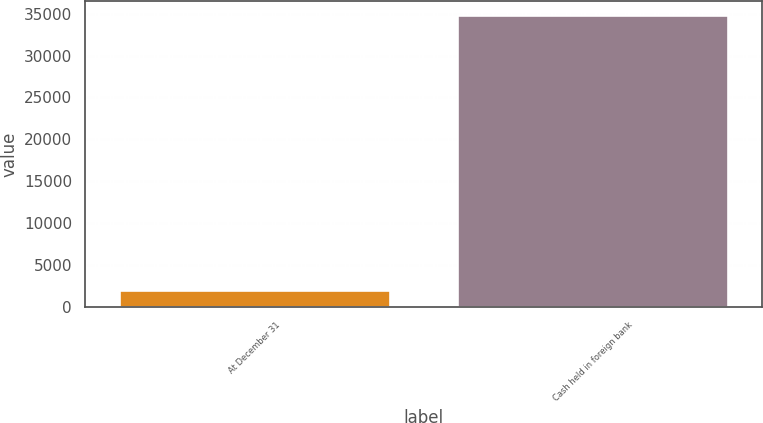Convert chart to OTSL. <chart><loc_0><loc_0><loc_500><loc_500><bar_chart><fcel>At December 31<fcel>Cash held in foreign bank<nl><fcel>2015<fcel>34816<nl></chart> 